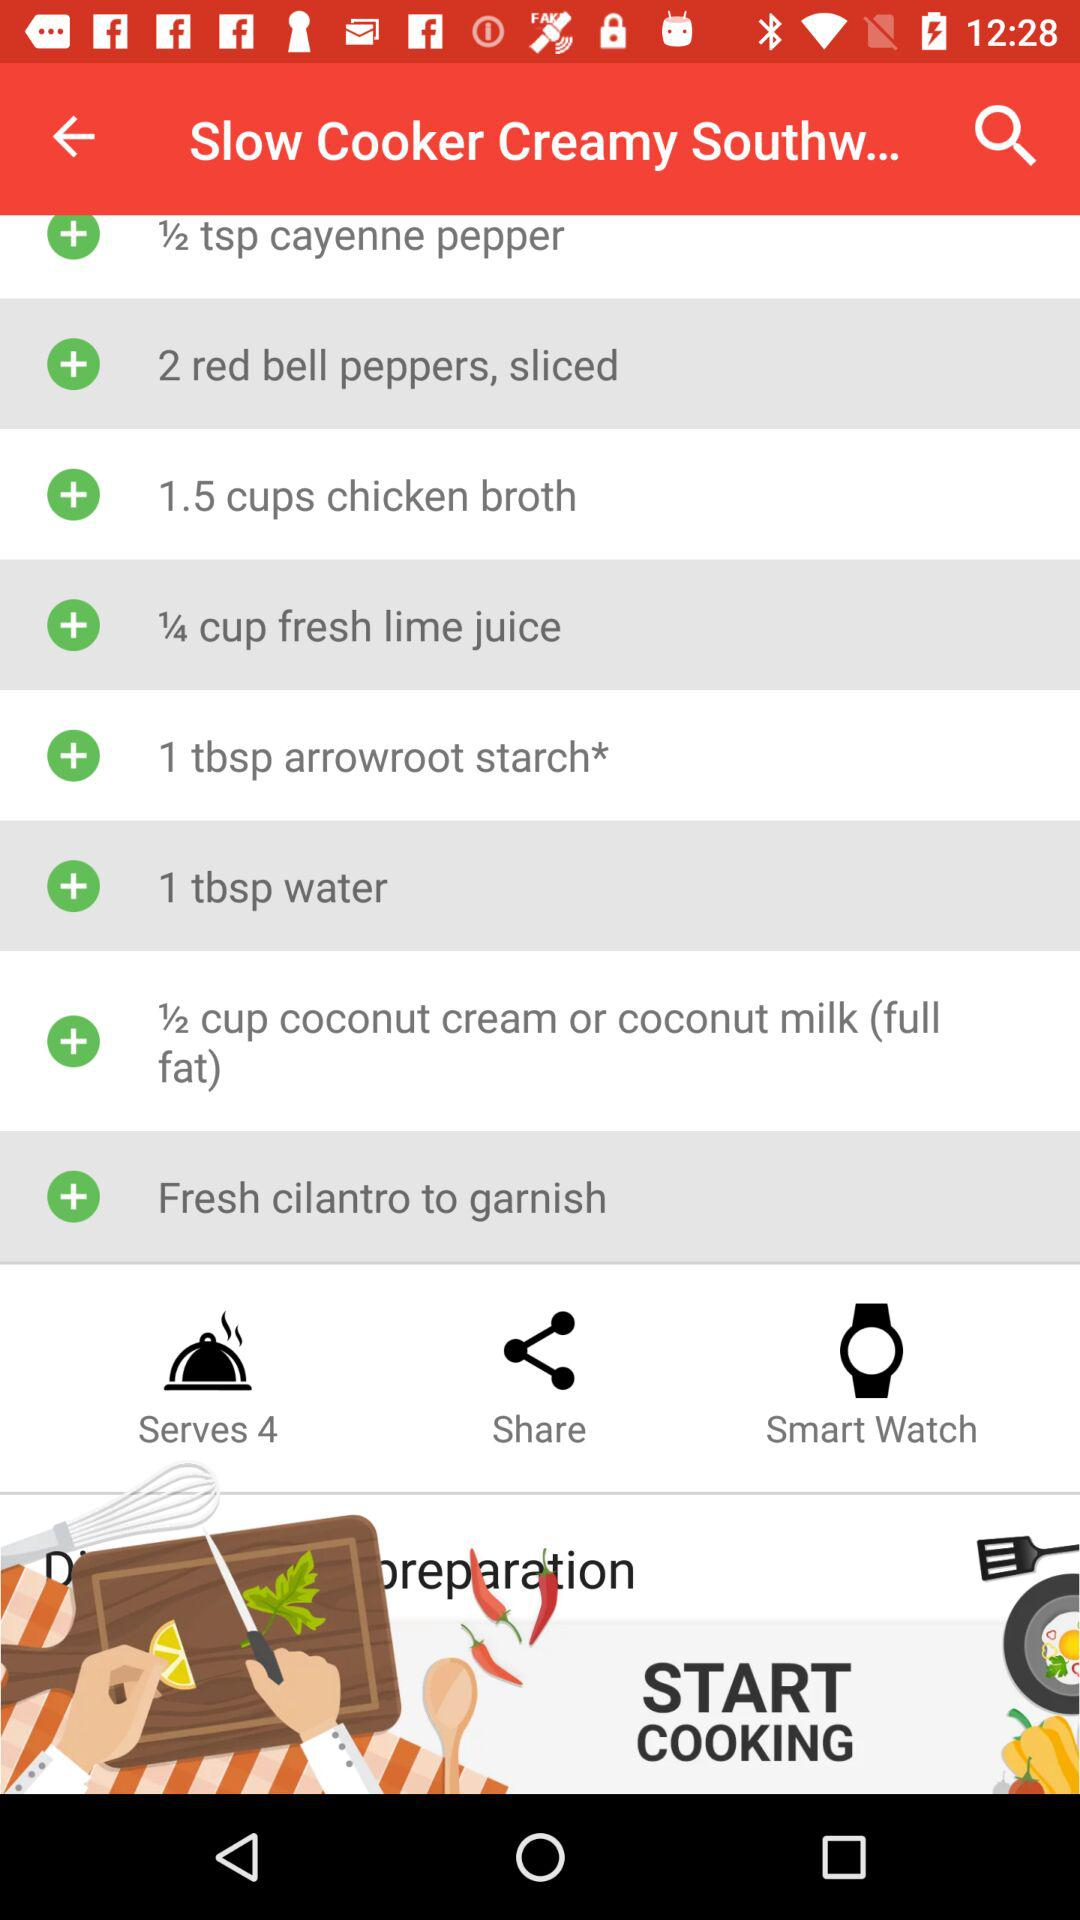How many cups of chicken broth are required? The required cups of chicken broth are 1.5. 